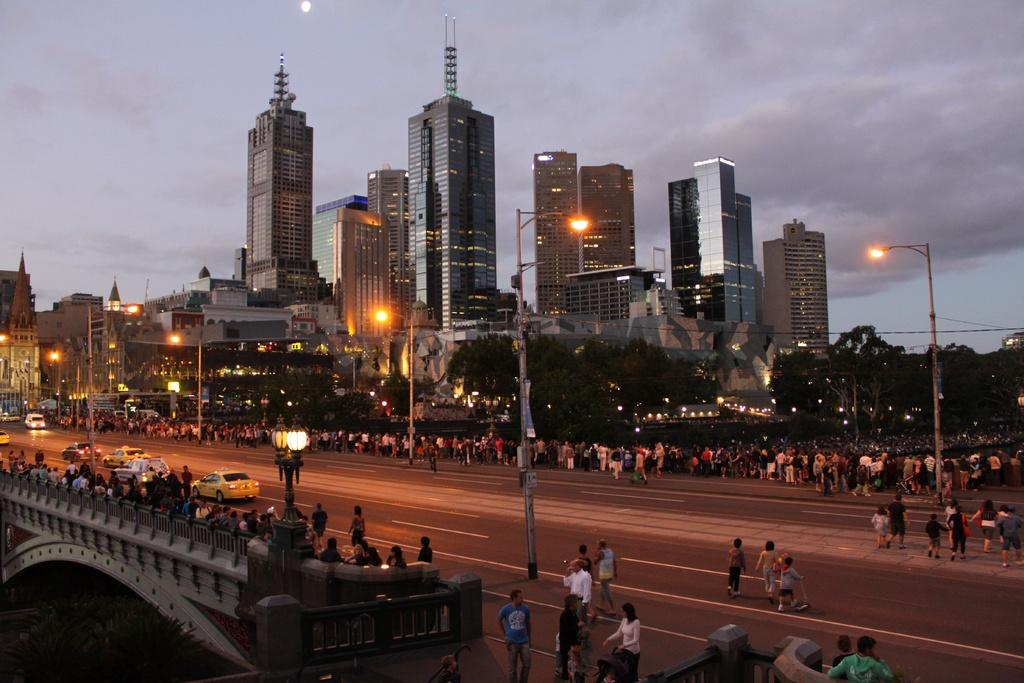What is the main feature of the image? There is a road in the image. What are the people in the image doing? There are people walking in the image. What type of structures can be seen in the image? There are buildings in the image. What is used to illuminate the road at night? There are street lights in the image. What is visible at the top of the image? The sky is visible at the top of the image. What type of bun is being used to hold the zinc in the image? There is no bun or zinc present in the image. How many sacks can be seen in the image? There are no sacks visible in the image. 